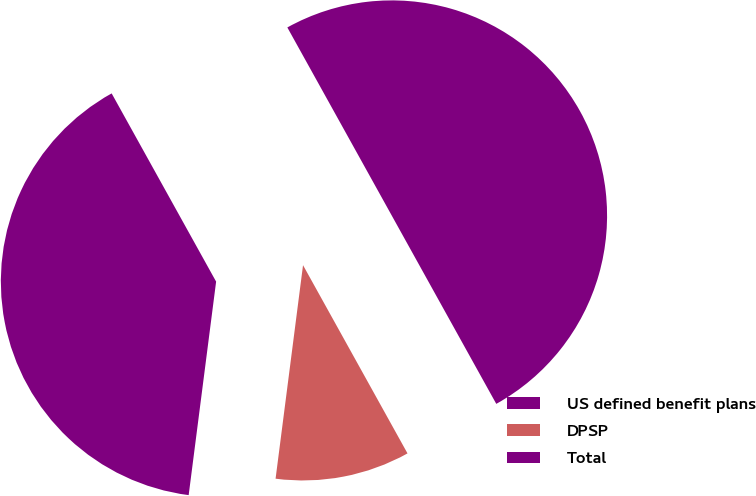Convert chart. <chart><loc_0><loc_0><loc_500><loc_500><pie_chart><fcel>US defined benefit plans<fcel>DPSP<fcel>Total<nl><fcel>39.9%<fcel>10.1%<fcel>50.0%<nl></chart> 